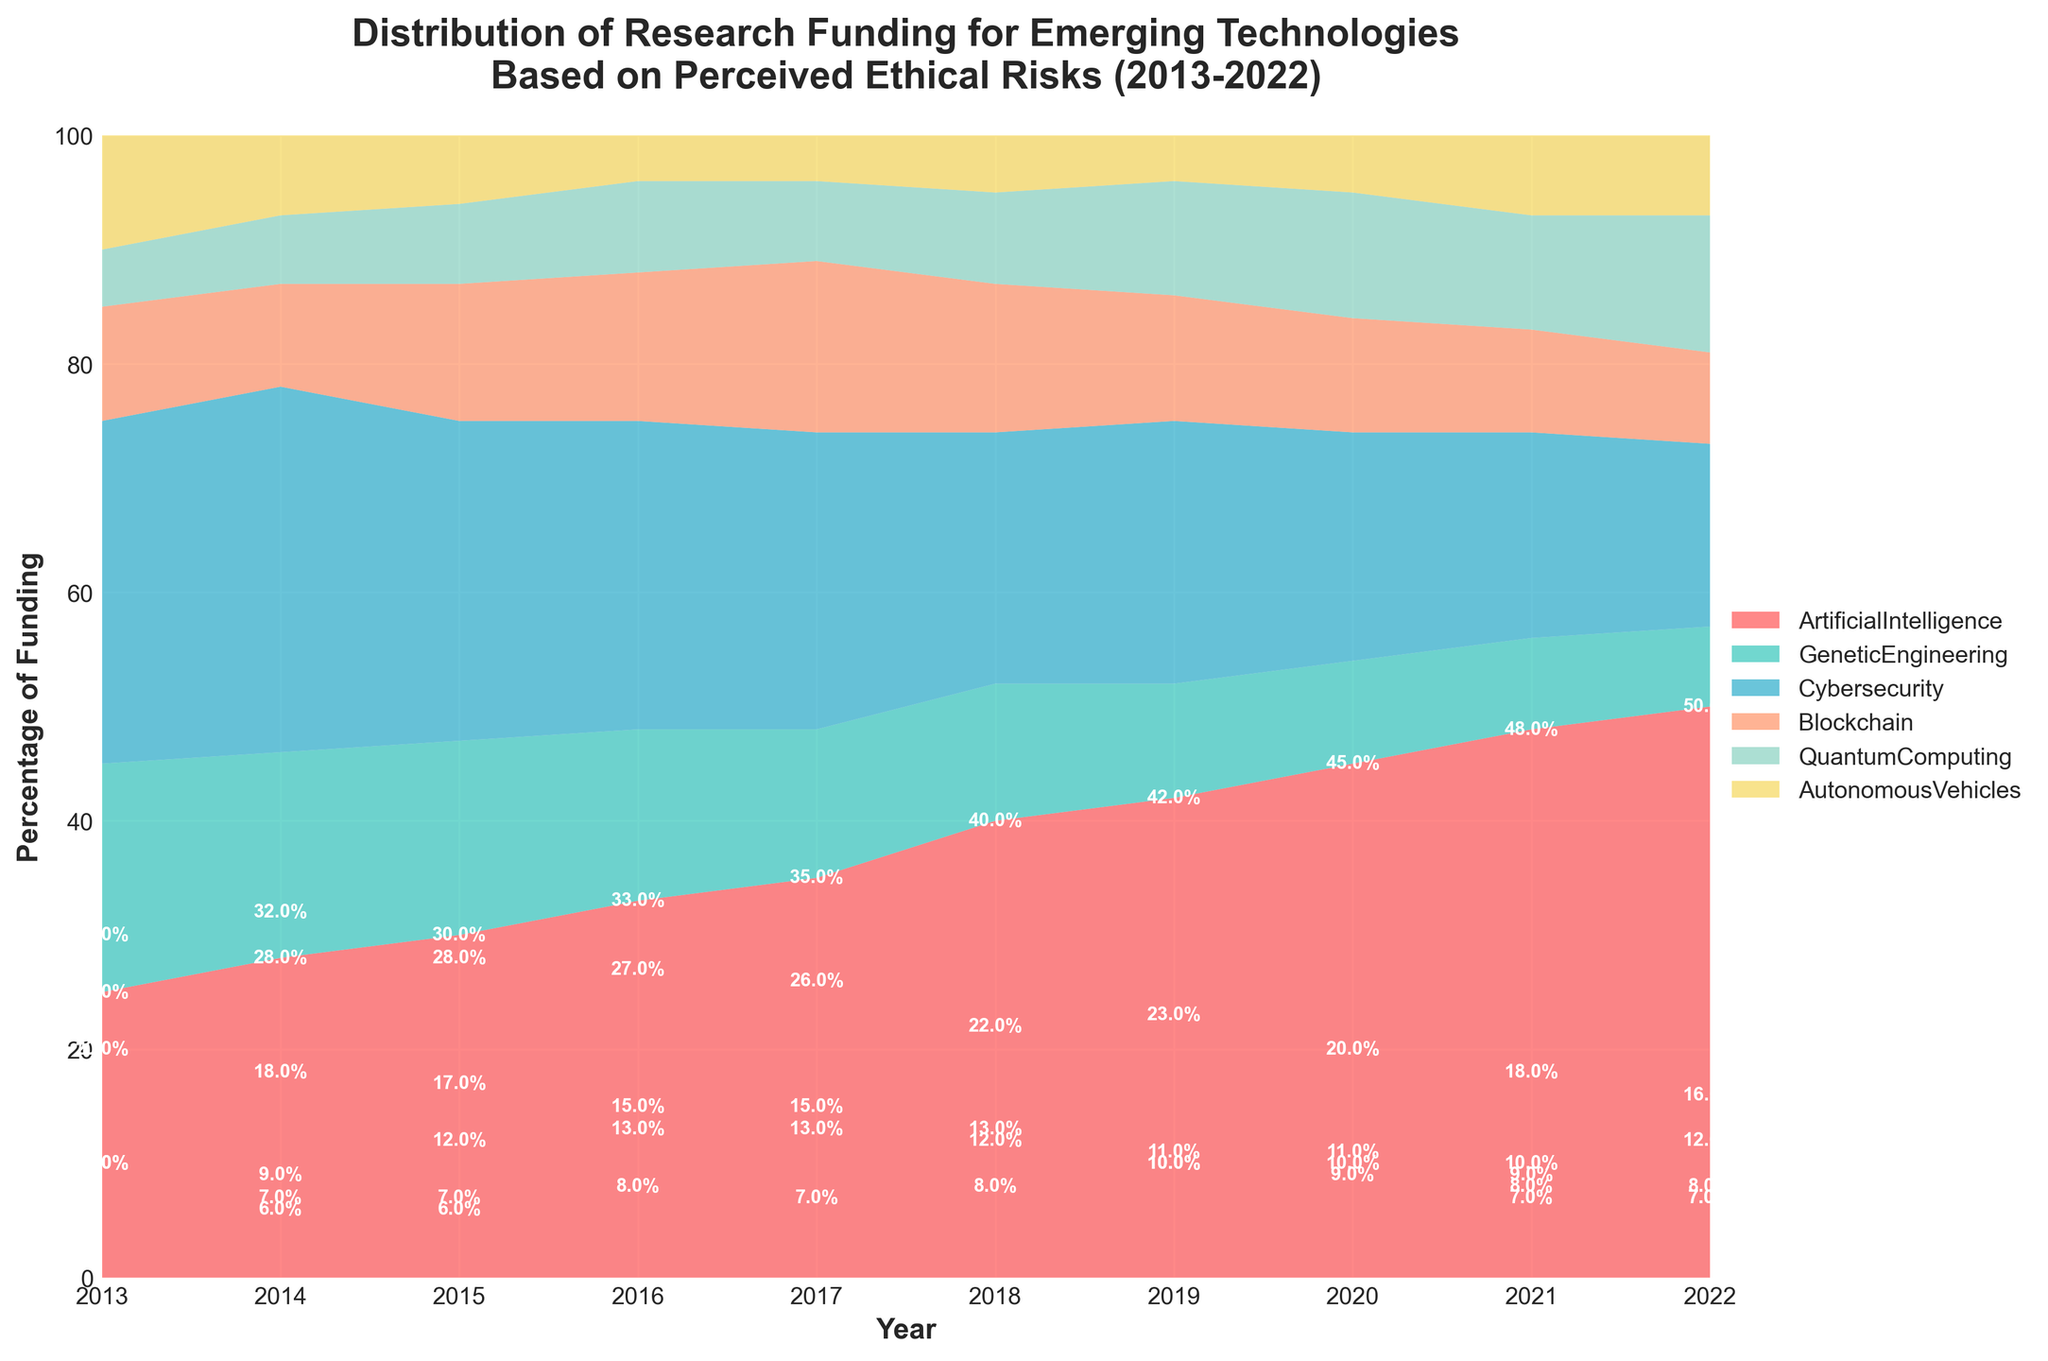What's the title of the figure? The title is usually found at the top of the chart and gives an overview of what the chart represents. In this case, the title indicates the distribution of research funding for various emerging technologies based on perceived ethical risks over a 10-year period.
Answer: Distribution of Research Funding for Emerging Technologies Based on Perceived Ethical Risks (2013-2022) Which technology received the highest funding percentage in 2022? To determine this, look at the last year (2022) on the x-axis and see which area has the largest vertical stack.
Answer: Artificial Intelligence How did the funding percentage for Genetic Engineering change over the 10 years? Examine the specific area representing Genetic Engineering from 2013 to 2022. Notice the trend in the height of the section.
Answer: Decreased What is the percentage of funding allocated to Quantum Computing in 2020? Follow the Quantum Computing area to the year 2020 on the x-axis and read the corresponding percentage on the y-axis.
Answer: 11% Compare the funding percentages for Cybersecurity and Blockchain in 2015. Which was higher and by how much? Check the height of the areas for Cybersecurity and Blockchain in 2015 and calculate the difference.
Answer: Cybersecurity was higher by 16% In which year did Autonomous Vehicles receive the least percentage of funding? Track the color assigned to Autonomous Vehicles across the years and identify the point of the smallest vertical height.
Answer: 2016 What's the overall trend for funding in Artificial Intelligence from 2013 to 2022? Look at the area dedicated to Artificial Intelligence from 2013 to 2022 and observe the direction of the change.
Answer: Increasing What is the difference in the percentage of funding between Blockchain and Quantum Computing in 2017? Locate the values for both Blockchain and Quantum Computing for the year 2017 and find the difference between them.
Answer: 8% On average, how much funding did Genetic Engineering receive over the 10 years? Sum the funding percentage for Genetic Engineering for each year and divide by 10. (20+18+17+15+13+12+10+9+8+7)/10 = 12.9%
Answer: 12.9% Which technology showed the most consistent funding percentage, and how can you tell? Examine the areas for each technology to see which one maintains a relatively consistent height over the years.
Answer: Autonomous Vehicles 